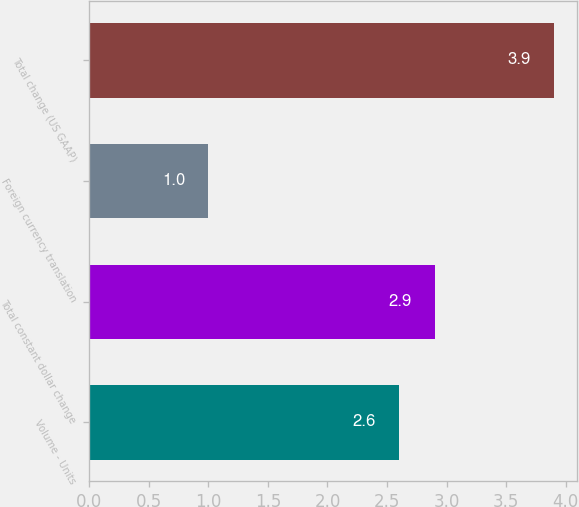<chart> <loc_0><loc_0><loc_500><loc_500><bar_chart><fcel>Volume - Units<fcel>Total constant dollar change<fcel>Foreign currency translation<fcel>Total change (US GAAP)<nl><fcel>2.6<fcel>2.9<fcel>1<fcel>3.9<nl></chart> 